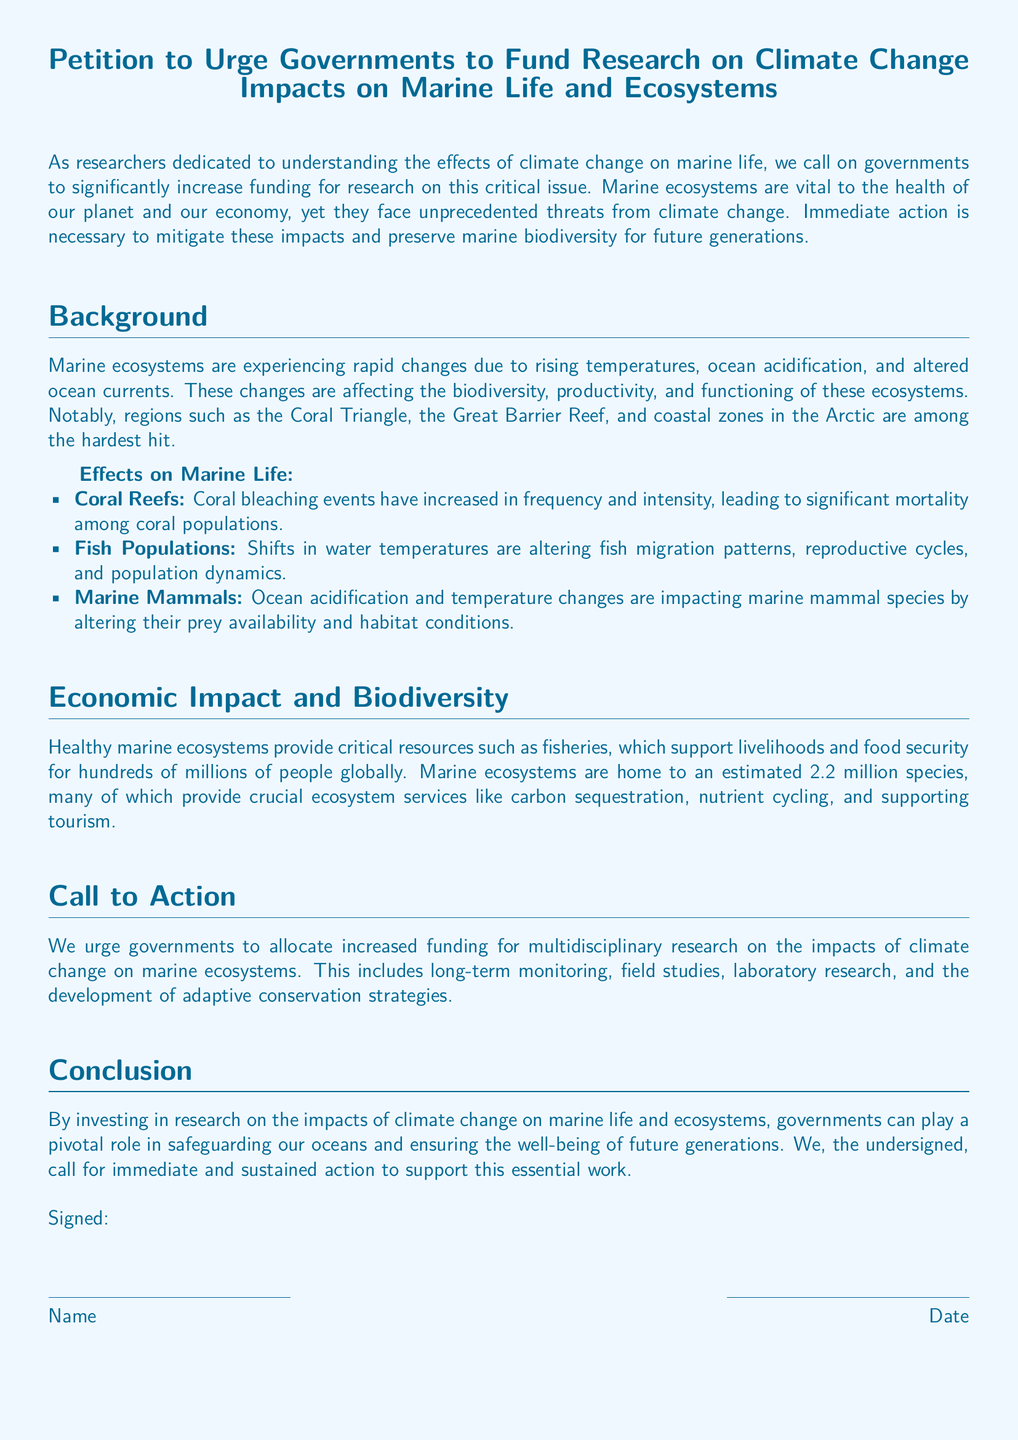what is the title of the petition? The title of the petition is stated at the top of the document.
Answer: Petition to Urge Governments to Fund Research on Climate Change Impacts on Marine Life and Ecosystems what are the three areas mentioned where marine ecosystems are hardest hit? The document lists specific regions that are affected in the background section.
Answer: Coral Triangle, the Great Barrier Reef, and coastal zones in the Arctic how many species are estimated to be in marine ecosystems? The document provides an estimate in the economic impact section.
Answer: 2.2 million species what is one effect of rising temperatures on fish populations? The document describes how environmental changes affect marine life, particularly fish.
Answer: Altering fish migration patterns what type of studies should governments fund according to the call to action? This section specifies the types of research that are being urged for funding.
Answer: Multidisciplinary research how does the petition categorize marine ecosystems? The document uses specific terminology to stress their importance.
Answer: Vital to the health of our planet and our economy what has increased in frequency and intensity that affects coral reefs? The document highlights a significant threat to coral reefs in the effects section.
Answer: Coral bleaching events what is the primary purpose of this petition? The petition's main objectives are outlined in the introduction.
Answer: To urge governments to significantly increase funding for research on climate change impacts on marine life 